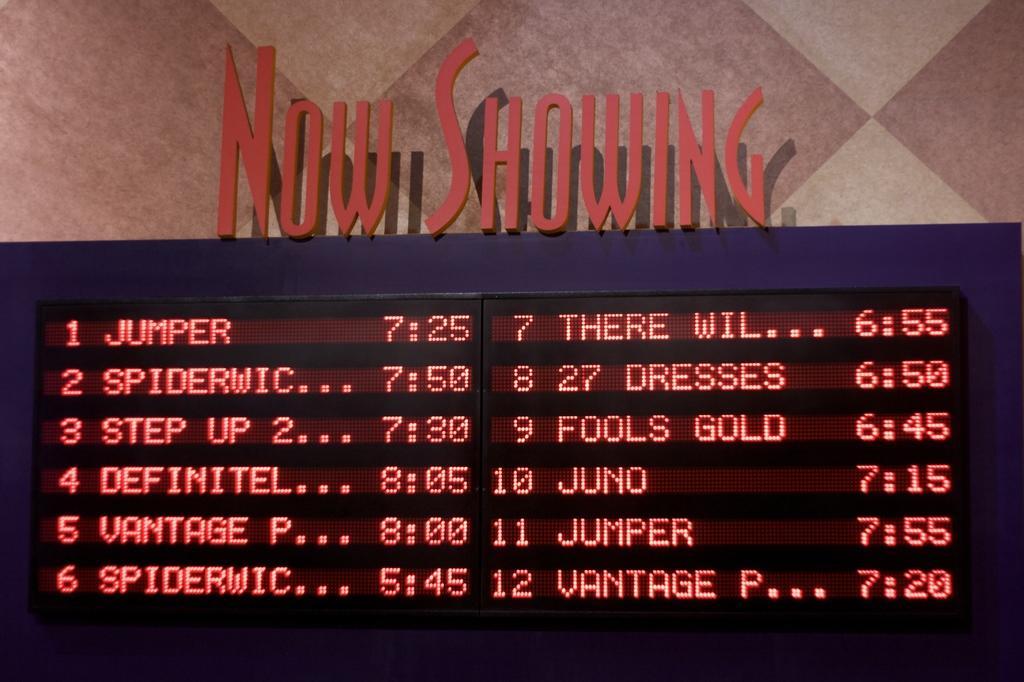Can you describe this image briefly? In this image in front there is a display board with the show timings. At the bottom of the image there is a floor. 